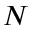Convert formula to latex. <formula><loc_0><loc_0><loc_500><loc_500>N</formula> 